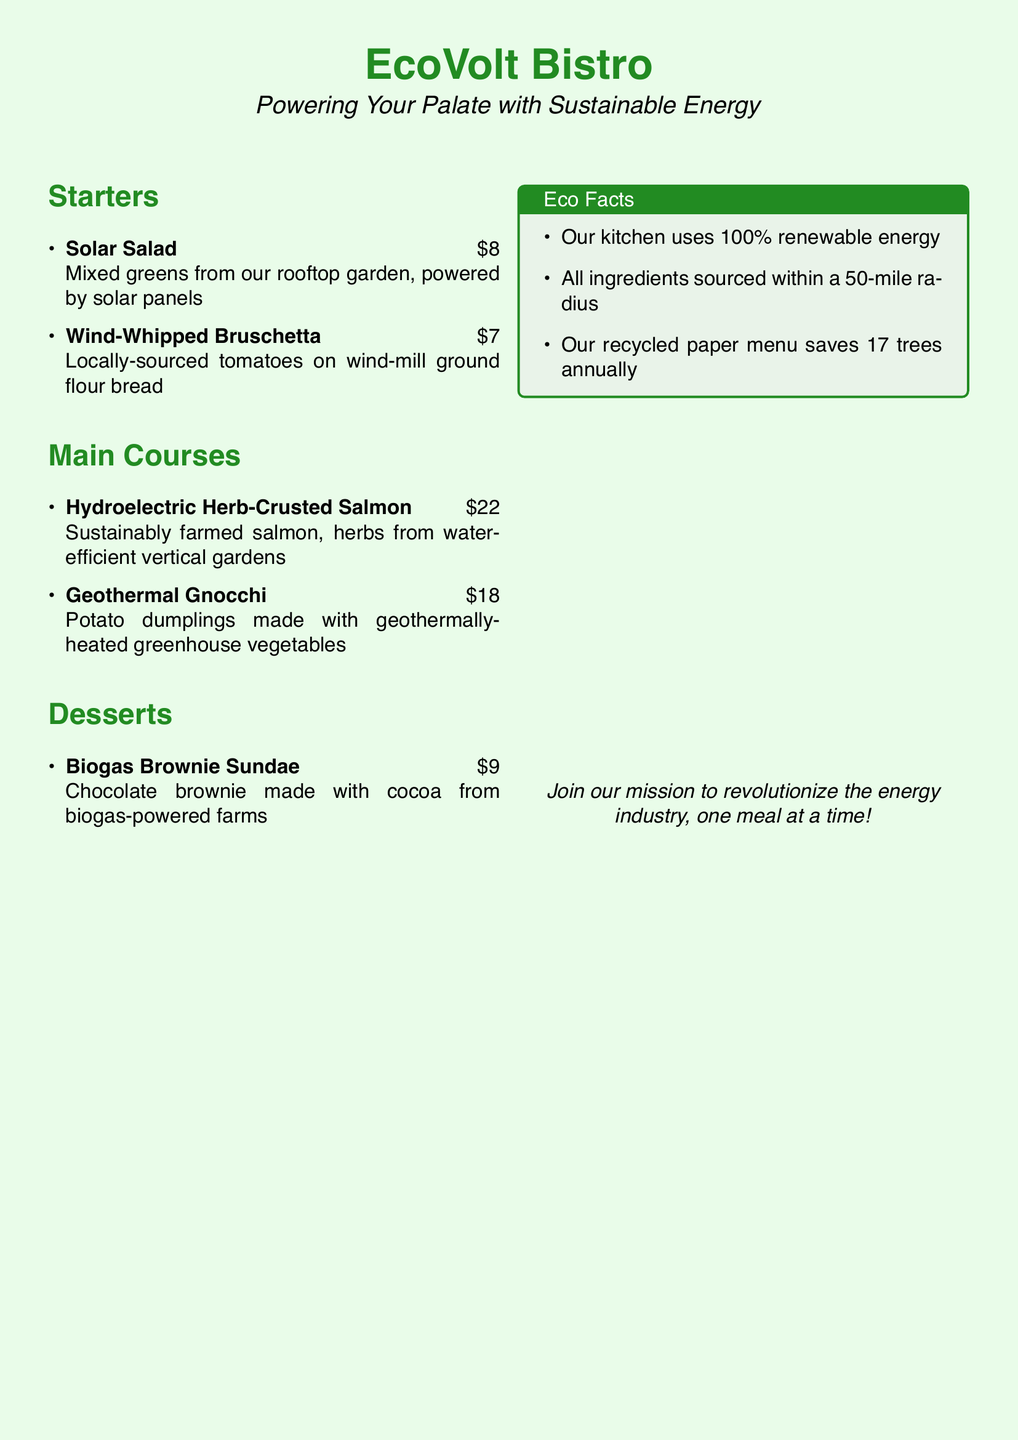What is the name of the restaurant? The title of the restaurant is presented at the top of the document as "EcoVolt Bistro."
Answer: EcoVolt Bistro What is the price of the Solar Salad? The price is directly listed next to the item on the menu.
Answer: $8 Which dessert is made with biogas-powered ingredients? This information is found in the description of the dessert section.
Answer: Biogas Brownie Sundae How much does the Geothermal Gnocchi cost? The cost is specified right after the dish name in the main courses section.
Answer: $18 What kind of energy does the kitchen use? The eco facts box specifies the type of energy used in the kitchen.
Answer: 100% renewable energy What is the sourcing radius for ingredients? This detail is mentioned in the eco facts section of the document.
Answer: 50-mile radius How many trees does the recycled paper menu save annually? The eco facts box explicitly provides this numerical value.
Answer: 17 trees What type of greens are used in the Solar Salad? The description of the dish indicates the source of the greens.
Answer: Mixed greens from our rooftop garden What unique feature does the Wind-Whipped Bruschetta offer? The description highlights that it uses flour from a specific type of grind.
Answer: Wind-mill ground flour bread 